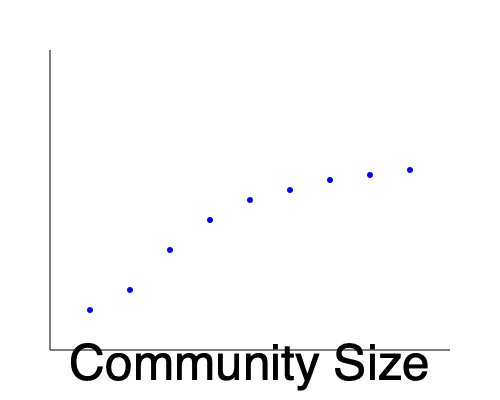Based on the scatter plot showing the relationship between community size and social cohesion index, what conclusion can be drawn about the impact of regional migration on social cohesion in small communities? How might this information inform community leadership strategies? To interpret this scatter plot and draw conclusions about the impact of regional migration on social cohesion in small communities, we need to follow these steps:

1. Observe the overall trend:
   The scatter plot shows a clear positive correlation between community size and social cohesion index. As community size increases, the social cohesion index generally increases as well.

2. Analyze the curve:
   The relationship appears to be non-linear. The rate of increase in social cohesion is steeper for smaller communities and tends to level off as community size grows larger.

3. Consider the context of regional migration:
   In the context of regional migration, we can infer that as people move into smaller communities, increasing their size, the social cohesion index tends to improve.

4. Interpret the implications for small communities:
   Smaller communities (represented by data points on the left side of the graph) have lower social cohesion indices. This suggests that very small communities might face challenges in maintaining strong social bonds.

5. Assess the potential benefits of growth:
   The steeper curve for smaller communities indicates that even modest increases in population size could lead to significant improvements in social cohesion for these communities.

6. Recognize the limitations:
   The relationship appears to have diminishing returns, as the curve flattens for larger community sizes. This suggests that beyond a certain point, further increases in population may not yield proportional improvements in social cohesion.

7. Consider implications for community leadership:
   Community leaders in smaller towns might consider strategies to attract migrants or prevent outmigration to reach a "sweet spot" in community size that maximizes social cohesion. However, they should also be aware that rapid or excessive growth might not always be beneficial.

8. Balance growth with community character:
   Leaders should aim to foster growth that enhances social cohesion while preserving the unique character and strengths of their small communities.

9. Develop targeted strategies:
   Based on this data, community leaders could develop strategies to enhance social cohesion that are tailored to their community's current size and desired growth trajectory.
Answer: Regional migration that increases community size generally improves social cohesion, especially in smaller communities, but with diminishing returns for larger populations. Community leaders should balance growth strategies with efforts to maintain community character and develop size-appropriate social cohesion initiatives. 